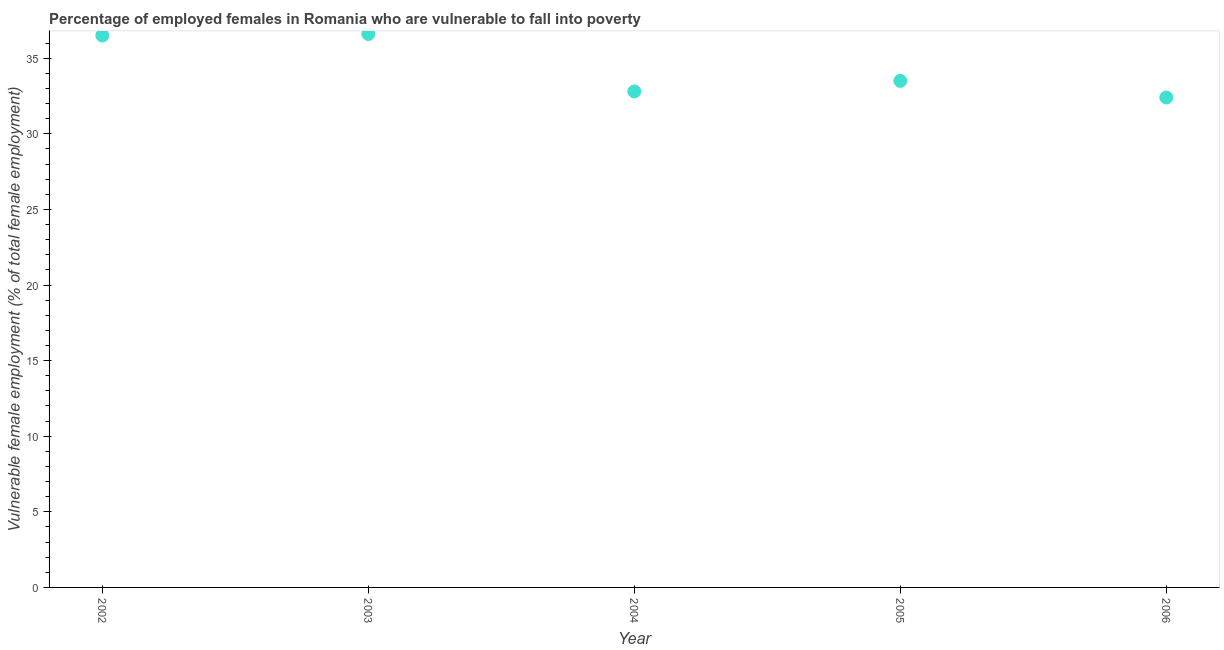What is the percentage of employed females who are vulnerable to fall into poverty in 2006?
Offer a very short reply. 32.4. Across all years, what is the maximum percentage of employed females who are vulnerable to fall into poverty?
Your answer should be compact. 36.6. Across all years, what is the minimum percentage of employed females who are vulnerable to fall into poverty?
Your response must be concise. 32.4. In which year was the percentage of employed females who are vulnerable to fall into poverty minimum?
Your response must be concise. 2006. What is the sum of the percentage of employed females who are vulnerable to fall into poverty?
Your answer should be compact. 171.8. What is the difference between the percentage of employed females who are vulnerable to fall into poverty in 2002 and 2006?
Your answer should be compact. 4.1. What is the average percentage of employed females who are vulnerable to fall into poverty per year?
Your response must be concise. 34.36. What is the median percentage of employed females who are vulnerable to fall into poverty?
Your answer should be compact. 33.5. What is the ratio of the percentage of employed females who are vulnerable to fall into poverty in 2002 to that in 2003?
Your answer should be compact. 1. What is the difference between the highest and the second highest percentage of employed females who are vulnerable to fall into poverty?
Provide a short and direct response. 0.1. Is the sum of the percentage of employed females who are vulnerable to fall into poverty in 2002 and 2005 greater than the maximum percentage of employed females who are vulnerable to fall into poverty across all years?
Give a very brief answer. Yes. What is the difference between the highest and the lowest percentage of employed females who are vulnerable to fall into poverty?
Give a very brief answer. 4.2. Does the percentage of employed females who are vulnerable to fall into poverty monotonically increase over the years?
Offer a terse response. No. How many dotlines are there?
Keep it short and to the point. 1. How many years are there in the graph?
Your answer should be very brief. 5. Does the graph contain grids?
Give a very brief answer. No. What is the title of the graph?
Offer a very short reply. Percentage of employed females in Romania who are vulnerable to fall into poverty. What is the label or title of the X-axis?
Your response must be concise. Year. What is the label or title of the Y-axis?
Your answer should be very brief. Vulnerable female employment (% of total female employment). What is the Vulnerable female employment (% of total female employment) in 2002?
Provide a succinct answer. 36.5. What is the Vulnerable female employment (% of total female employment) in 2003?
Offer a very short reply. 36.6. What is the Vulnerable female employment (% of total female employment) in 2004?
Ensure brevity in your answer.  32.8. What is the Vulnerable female employment (% of total female employment) in 2005?
Make the answer very short. 33.5. What is the Vulnerable female employment (% of total female employment) in 2006?
Offer a very short reply. 32.4. What is the difference between the Vulnerable female employment (% of total female employment) in 2002 and 2003?
Keep it short and to the point. -0.1. What is the difference between the Vulnerable female employment (% of total female employment) in 2002 and 2004?
Provide a short and direct response. 3.7. What is the difference between the Vulnerable female employment (% of total female employment) in 2002 and 2005?
Your answer should be compact. 3. What is the difference between the Vulnerable female employment (% of total female employment) in 2004 and 2006?
Make the answer very short. 0.4. What is the difference between the Vulnerable female employment (% of total female employment) in 2005 and 2006?
Make the answer very short. 1.1. What is the ratio of the Vulnerable female employment (% of total female employment) in 2002 to that in 2003?
Ensure brevity in your answer.  1. What is the ratio of the Vulnerable female employment (% of total female employment) in 2002 to that in 2004?
Offer a very short reply. 1.11. What is the ratio of the Vulnerable female employment (% of total female employment) in 2002 to that in 2005?
Offer a very short reply. 1.09. What is the ratio of the Vulnerable female employment (% of total female employment) in 2002 to that in 2006?
Make the answer very short. 1.13. What is the ratio of the Vulnerable female employment (% of total female employment) in 2003 to that in 2004?
Offer a very short reply. 1.12. What is the ratio of the Vulnerable female employment (% of total female employment) in 2003 to that in 2005?
Give a very brief answer. 1.09. What is the ratio of the Vulnerable female employment (% of total female employment) in 2003 to that in 2006?
Your answer should be compact. 1.13. What is the ratio of the Vulnerable female employment (% of total female employment) in 2004 to that in 2006?
Keep it short and to the point. 1.01. What is the ratio of the Vulnerable female employment (% of total female employment) in 2005 to that in 2006?
Ensure brevity in your answer.  1.03. 